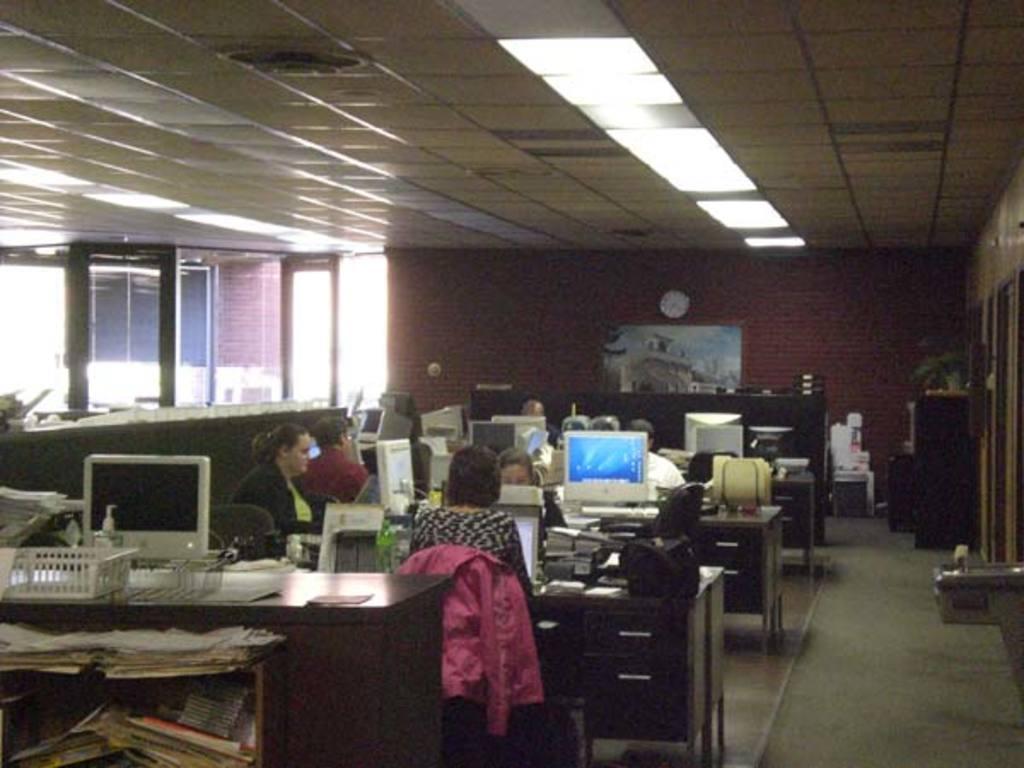How would you summarize this image in a sentence or two? In this image I can see the group of people sitting in-front of the desk. On the desk where are the systems,books and the bags. In the background there is a window and the frame to the wall. 